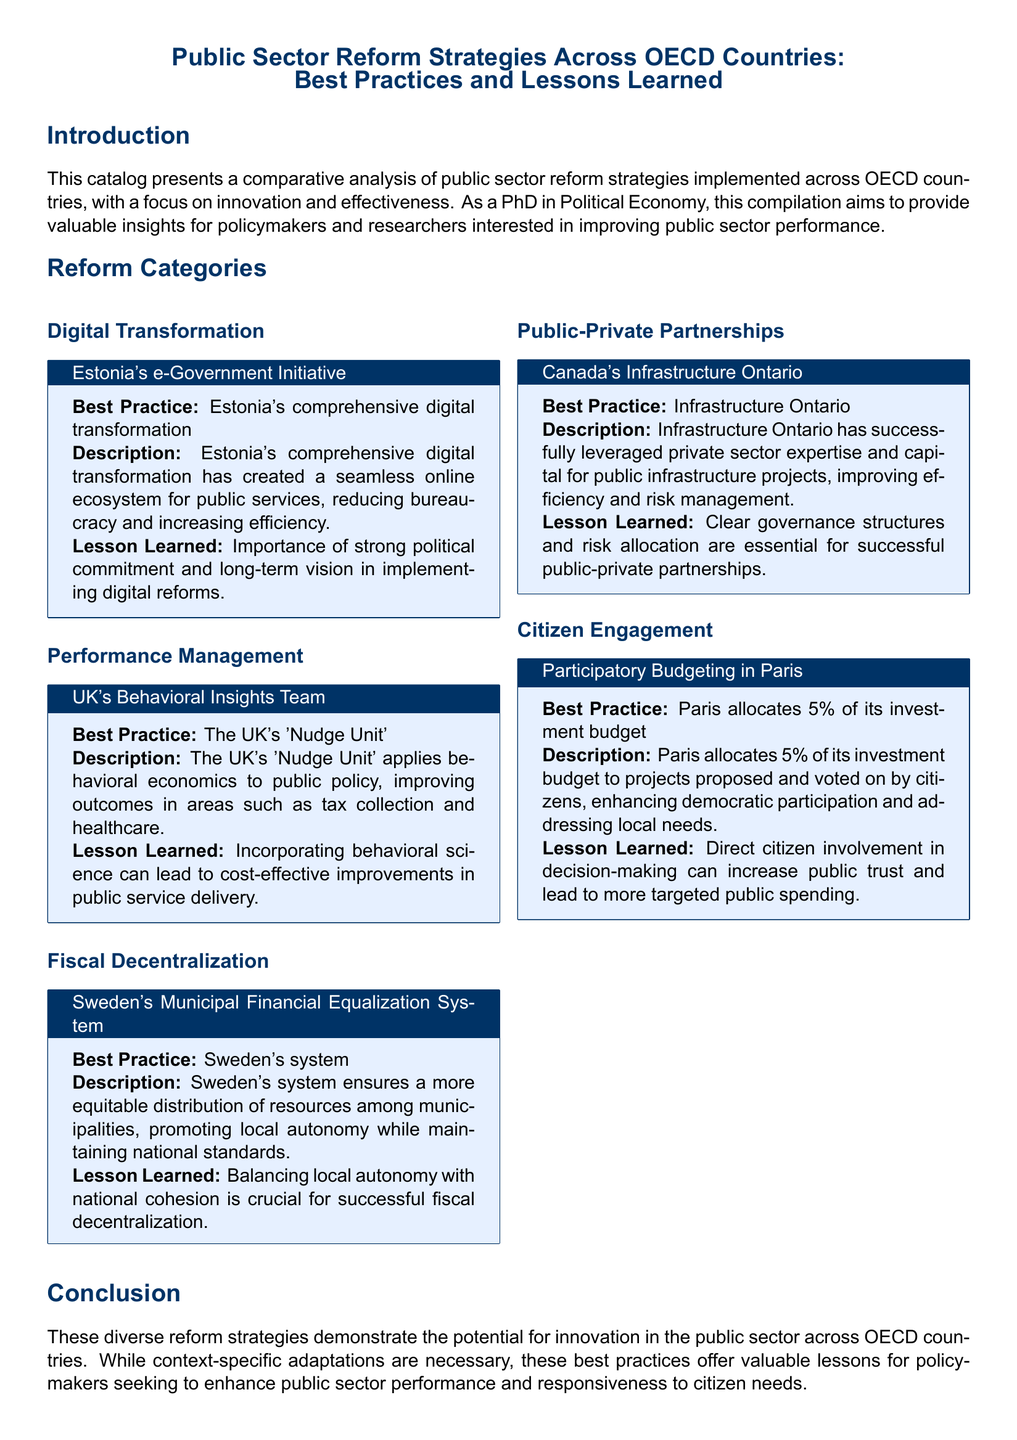What is the title of the document? The title of the document is stated at the beginning of the catalog.
Answer: Public Sector Reform Strategies Across OECD Countries: Best Practices and Lessons Learned Which country implemented the e-Government Initiative? The e-Government Initiative is specifically associated with one OECD country mentioned in the document.
Answer: Estonia What percentage of Paris's investment budget is allocated to participatory projects? The document explicitly states the percentage of the investment budget allocated by Paris for citizen-proposed projects.
Answer: 5% What type of reform does the UK's 'Nudge Unit' focus on? The document describes the focus area of the UK's 'Nudge Unit' related to public policy.
Answer: Behavioral economics What is a key ingredient for successful public-private partnerships in Canada? The document mentions essential elements for public-private partnerships, particularly in Canada.
Answer: Clear governance structures How does Sweden's Municipal Financial Equalization System benefit municipalities? The document explains the benefit of the system related to local autonomy and equity.
Answer: Equitable distribution of resources What lesson is learned from Estonia's digital transformation? The document lists lessons learned from implementing digital reforms in Estonia.
Answer: Importance of strong political commitment What category of reform does citizen engagement fall under? The document categorizes various reform strategies, including citizen engagement.
Answer: Citizen Engagement 